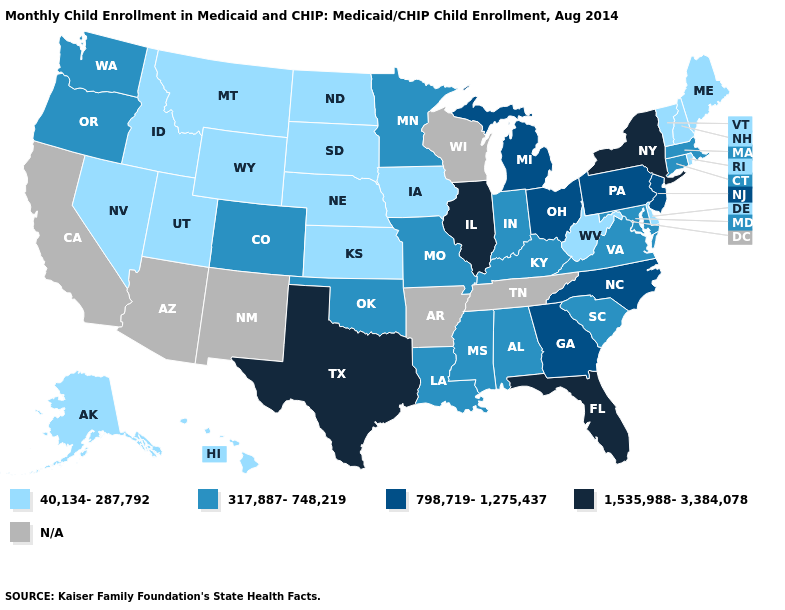What is the value of Colorado?
Write a very short answer. 317,887-748,219. What is the value of Washington?
Concise answer only. 317,887-748,219. What is the highest value in states that border Tennessee?
Be succinct. 798,719-1,275,437. Name the states that have a value in the range 317,887-748,219?
Quick response, please. Alabama, Colorado, Connecticut, Indiana, Kentucky, Louisiana, Maryland, Massachusetts, Minnesota, Mississippi, Missouri, Oklahoma, Oregon, South Carolina, Virginia, Washington. What is the value of Kentucky?
Quick response, please. 317,887-748,219. What is the value of California?
Short answer required. N/A. What is the value of Georgia?
Write a very short answer. 798,719-1,275,437. Among the states that border Connecticut , which have the highest value?
Answer briefly. New York. Does Illinois have the lowest value in the MidWest?
Concise answer only. No. Does Alaska have the highest value in the West?
Give a very brief answer. No. What is the value of Maine?
Write a very short answer. 40,134-287,792. What is the highest value in the USA?
Answer briefly. 1,535,988-3,384,078. What is the highest value in the South ?
Be succinct. 1,535,988-3,384,078. Which states have the highest value in the USA?
Short answer required. Florida, Illinois, New York, Texas. 